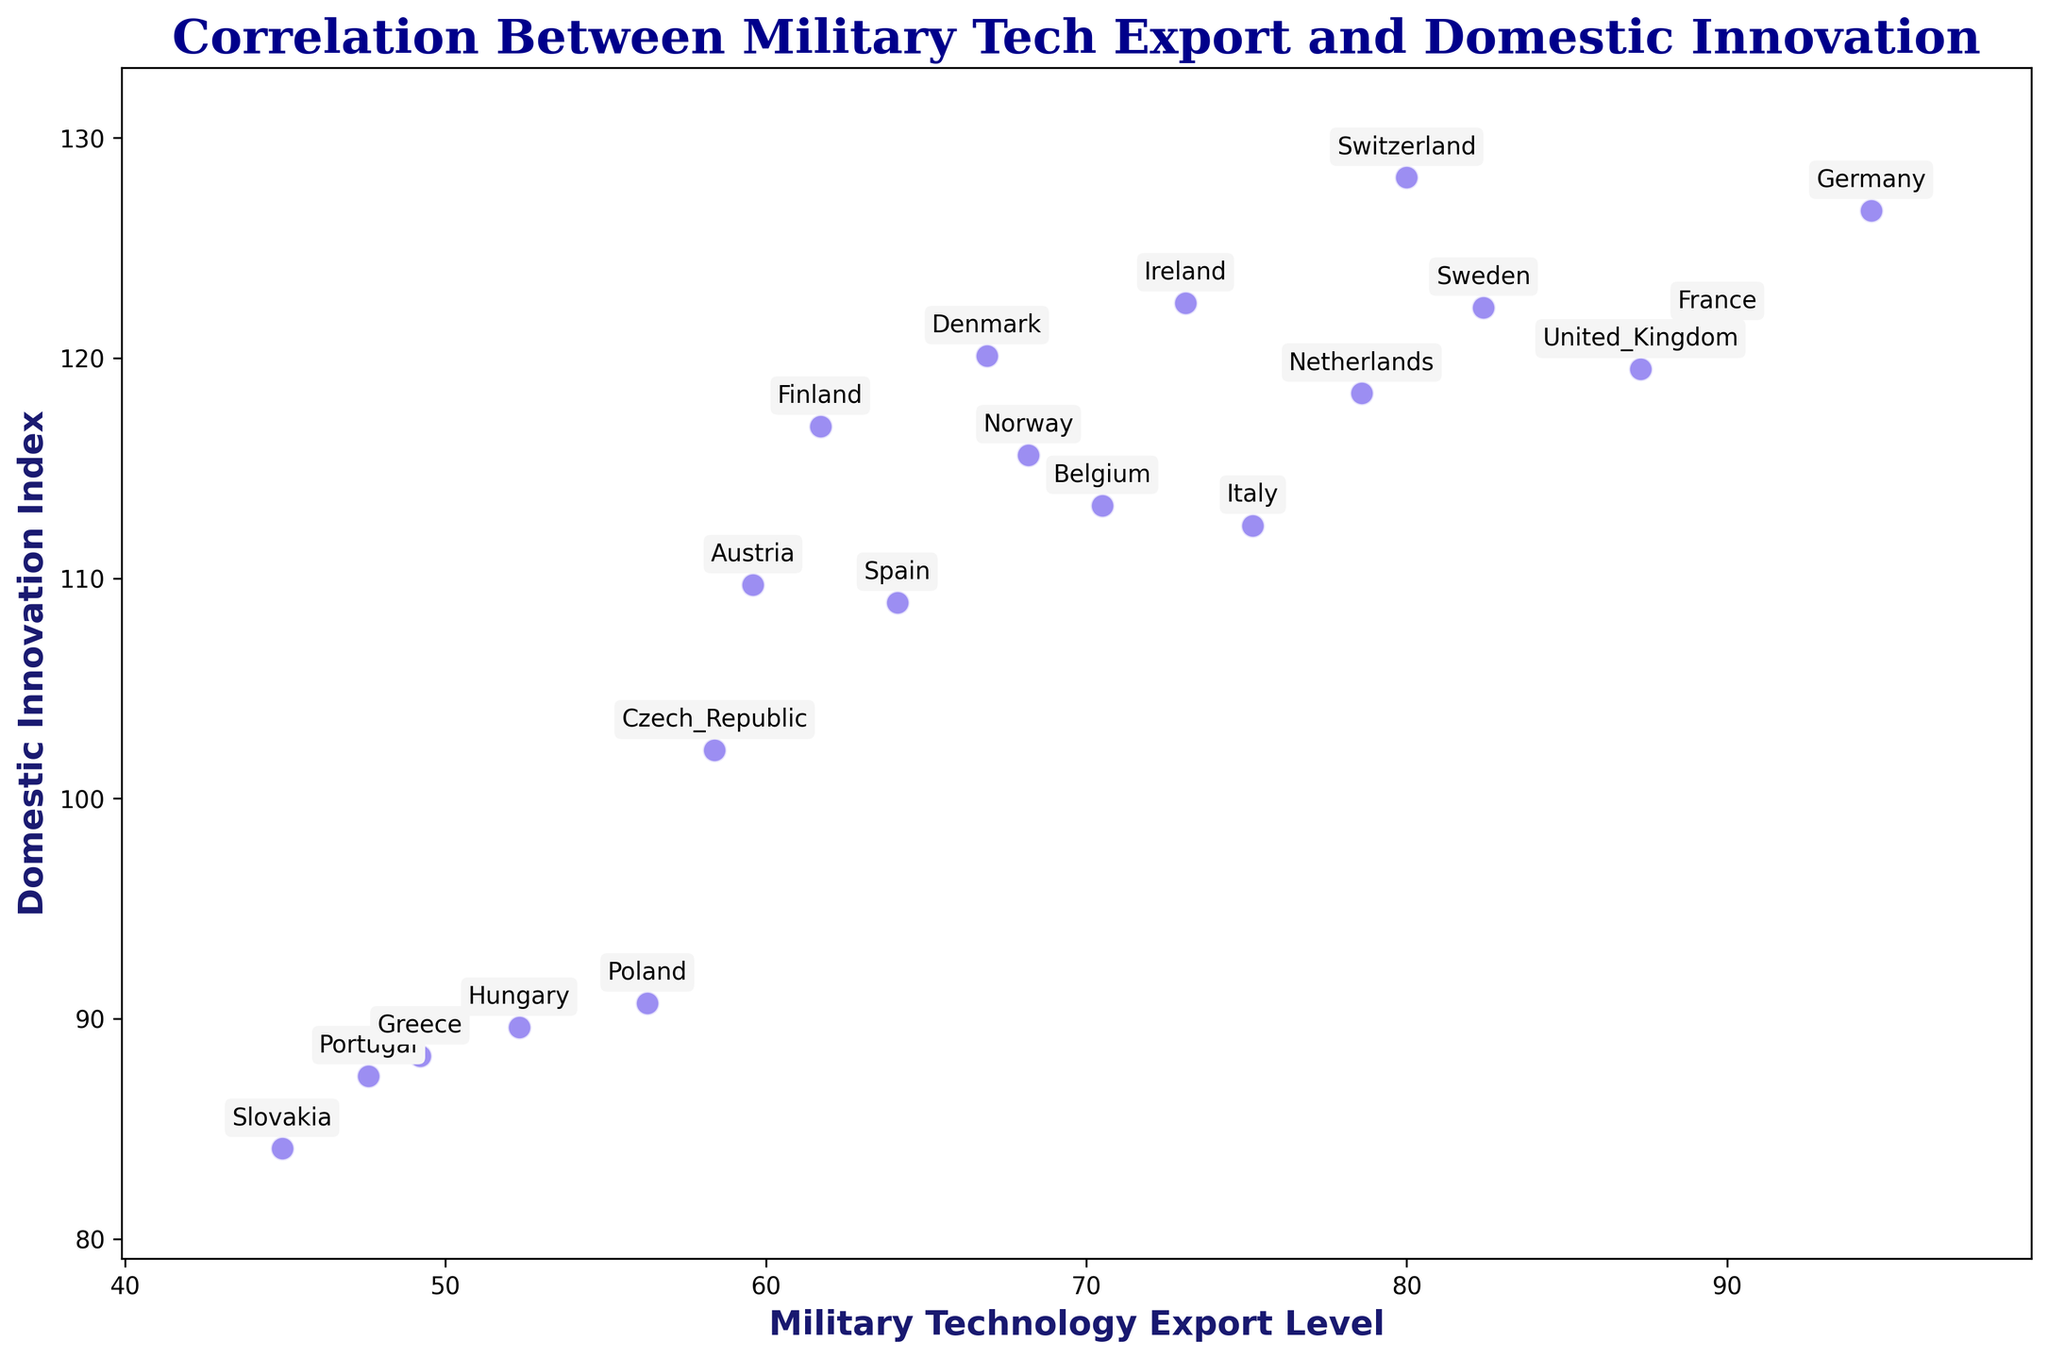What country has the highest Domestic Innovation Index? By observing the scatter plot, locate the point that has the highest value on the y-axis (Domestic Innovation Index) and check the country annotation for that point.
Answer: Switzerland Which countries have a Domestic Innovation Index greater than 120? Identify and list the countries where the y-values (Domestic Innovation Index) of their points are greater than 120.
Answer: Germany, France, Sweden, Denmark, Ireland, Switzerland Which country has the lowest Military Technology Export Level? Find the point located furthest left on the x-axis (Military Technology Export Level) and read the country annotation.
Answer: Slovakia Is there a country with a Domestic Innovation Index between 110 and 115 and a Military Technology Export Level above 70? Look for a point between 110 and 115 on the y-axis and check if its x-value is greater than 70.
Answer: Belgium How does Germany's Military Technology Export Level compare to France? Compare the x-value of the points for Germany and France.
Answer: Germany has a higher Military Technology Export Level than France What is the approximate difference in the Domestic Innovation Index between Poland and Portugal? Subtract the Domestic Innovation Index of Portugal from Poland. Poland's index is approximately 90.7, and Portugal's is approximately 87.4, so 90.7 - 87.4.
Answer: 3.3 Which country has a similar Military Technology Export Level to the Netherlands but a higher Domestic Innovation Index? First, find the point representing the Netherlands. Then look for any point with a similar x-value but a higher y-value.
Answer: Sweden Do any countries have both a Military Technology Export Level less than 50 and a Domestic Innovation Index less than 90? Check if any points lie to the left of 50 on the x-axis and below 90 on the y-axis simultaneously.
Answer: Hungary, Slovakia What is the overall trend between Military Technology Export Levels and Domestic Innovation Index? Analyze whether the points generally form an upward or downward trend from left to right and describe it.
Answer: There is a positive correlation 